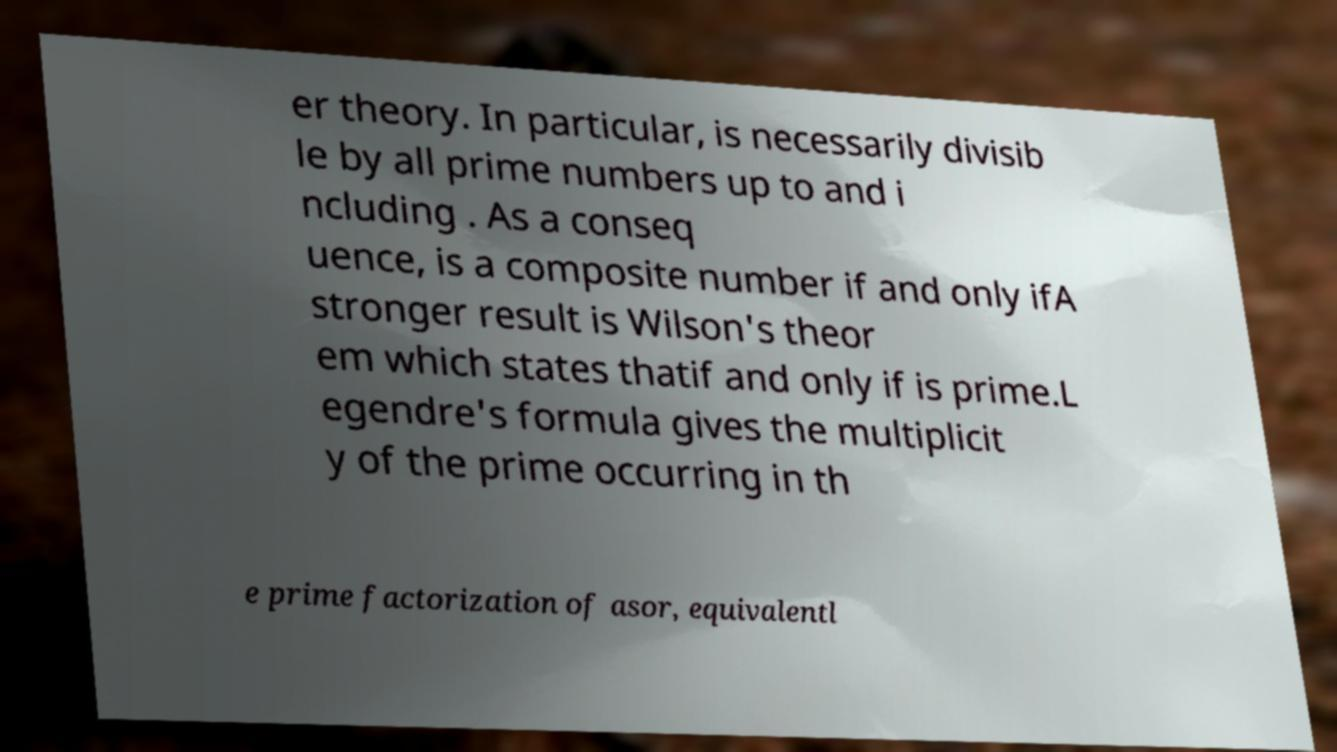Can you accurately transcribe the text from the provided image for me? er theory. In particular, is necessarily divisib le by all prime numbers up to and i ncluding . As a conseq uence, is a composite number if and only ifA stronger result is Wilson's theor em which states thatif and only if is prime.L egendre's formula gives the multiplicit y of the prime occurring in th e prime factorization of asor, equivalentl 